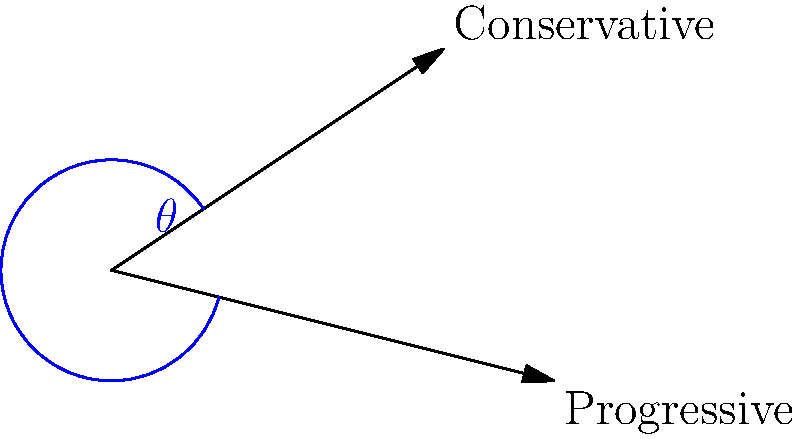In a 2D political ideology space, the Conservative vector is represented by (3, 2) and the Progressive vector by (4, -1). Calculate the angle $\theta$ between these two ideologies, rounded to the nearest degree. To find the angle between two vectors, we can use the dot product formula:

1) The dot product formula: $\cos \theta = \frac{\vec{a} \cdot \vec{b}}{|\vec{a}||\vec{b}|}$

2) Calculate the dot product:
   $\vec{a} \cdot \vec{b} = 3(4) + 2(-1) = 12 - 2 = 10$

3) Calculate the magnitudes:
   $|\vec{a}| = \sqrt{3^2 + 2^2} = \sqrt{13}$
   $|\vec{b}| = \sqrt{4^2 + (-1)^2} = \sqrt{17}$

4) Substitute into the formula:
   $\cos \theta = \frac{10}{\sqrt{13}\sqrt{17}}$

5) Take the inverse cosine (arccos) of both sides:
   $\theta = \arccos(\frac{10}{\sqrt{13}\sqrt{17}})$

6) Calculate and round to the nearest degree:
   $\theta \approx 44°$
Answer: 44° 